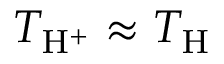Convert formula to latex. <formula><loc_0><loc_0><loc_500><loc_500>T _ { H ^ { + } } \approx T _ { H }</formula> 